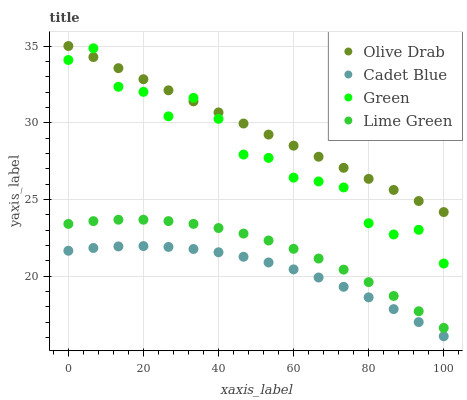Does Cadet Blue have the minimum area under the curve?
Answer yes or no. Yes. Does Olive Drab have the maximum area under the curve?
Answer yes or no. Yes. Does Green have the minimum area under the curve?
Answer yes or no. No. Does Green have the maximum area under the curve?
Answer yes or no. No. Is Olive Drab the smoothest?
Answer yes or no. Yes. Is Green the roughest?
Answer yes or no. Yes. Is Cadet Blue the smoothest?
Answer yes or no. No. Is Cadet Blue the roughest?
Answer yes or no. No. Does Cadet Blue have the lowest value?
Answer yes or no. Yes. Does Green have the lowest value?
Answer yes or no. No. Does Olive Drab have the highest value?
Answer yes or no. Yes. Does Green have the highest value?
Answer yes or no. No. Is Cadet Blue less than Olive Drab?
Answer yes or no. Yes. Is Green greater than Lime Green?
Answer yes or no. Yes. Does Green intersect Olive Drab?
Answer yes or no. Yes. Is Green less than Olive Drab?
Answer yes or no. No. Is Green greater than Olive Drab?
Answer yes or no. No. Does Cadet Blue intersect Olive Drab?
Answer yes or no. No. 